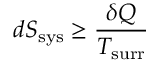<formula> <loc_0><loc_0><loc_500><loc_500>d S _ { s y s } \geq { \frac { \delta Q } { T _ { s u r r } } }</formula> 